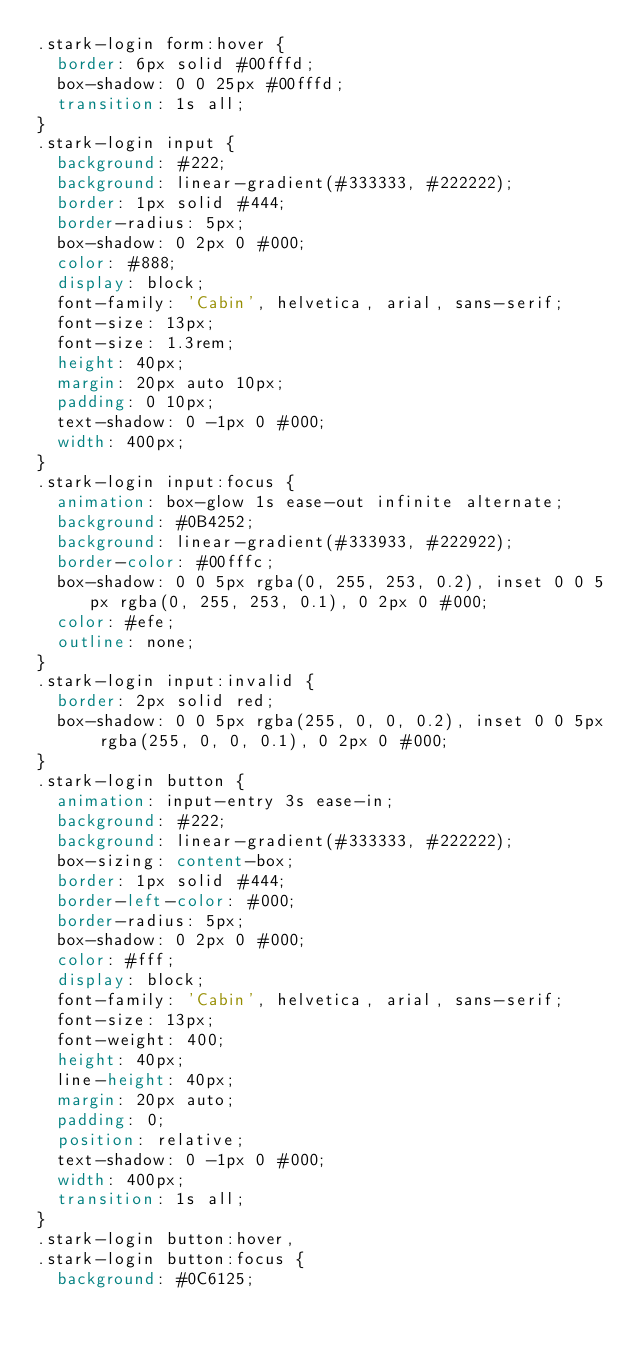<code> <loc_0><loc_0><loc_500><loc_500><_CSS_>.stark-login form:hover {
  border: 6px solid #00fffd;
  box-shadow: 0 0 25px #00fffd;
  transition: 1s all;
}
.stark-login input {
  background: #222;
  background: linear-gradient(#333333, #222222);
  border: 1px solid #444;
  border-radius: 5px;
  box-shadow: 0 2px 0 #000;
  color: #888;
  display: block;
  font-family: 'Cabin', helvetica, arial, sans-serif;
  font-size: 13px;
  font-size: 1.3rem;
  height: 40px;
  margin: 20px auto 10px;
  padding: 0 10px;
  text-shadow: 0 -1px 0 #000;
  width: 400px;
}
.stark-login input:focus {
  animation: box-glow 1s ease-out infinite alternate;
  background: #0B4252;
  background: linear-gradient(#333933, #222922);
  border-color: #00fffc;
  box-shadow: 0 0 5px rgba(0, 255, 253, 0.2), inset 0 0 5px rgba(0, 255, 253, 0.1), 0 2px 0 #000;
  color: #efe;
  outline: none;
}
.stark-login input:invalid {
  border: 2px solid red;
  box-shadow: 0 0 5px rgba(255, 0, 0, 0.2), inset 0 0 5px rgba(255, 0, 0, 0.1), 0 2px 0 #000;
}
.stark-login button {
  animation: input-entry 3s ease-in;
  background: #222;
  background: linear-gradient(#333333, #222222);
  box-sizing: content-box;
  border: 1px solid #444;
  border-left-color: #000;
  border-radius: 5px;
  box-shadow: 0 2px 0 #000;
  color: #fff;
  display: block;
  font-family: 'Cabin', helvetica, arial, sans-serif;
  font-size: 13px;
  font-weight: 400;
  height: 40px;
  line-height: 40px;
  margin: 20px auto;
  padding: 0;
  position: relative;
  text-shadow: 0 -1px 0 #000;
  width: 400px;
  transition: 1s all;
}
.stark-login button:hover,
.stark-login button:focus {
  background: #0C6125;</code> 